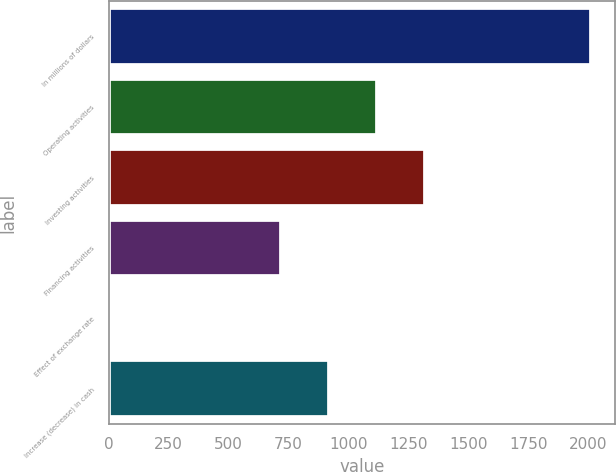Convert chart. <chart><loc_0><loc_0><loc_500><loc_500><bar_chart><fcel>In millions of dollars<fcel>Operating activities<fcel>Investing activities<fcel>Financing activities<fcel>Effect of exchange rate<fcel>Increase (decrease) in cash<nl><fcel>2014<fcel>1120.86<fcel>1321.64<fcel>719.3<fcel>6.2<fcel>920.08<nl></chart> 